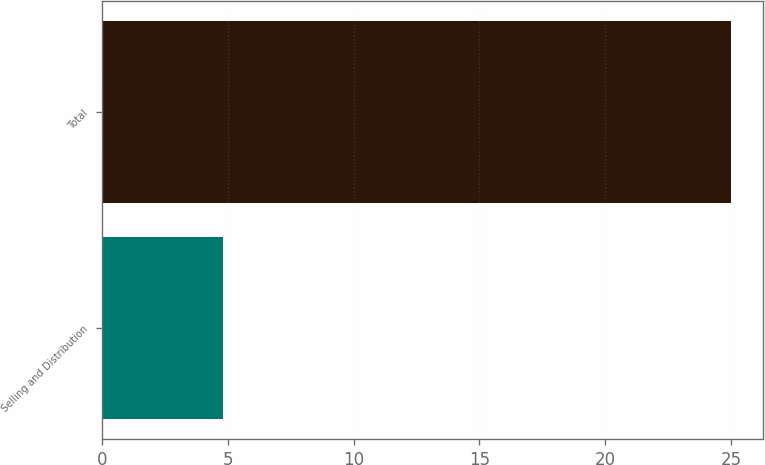Convert chart to OTSL. <chart><loc_0><loc_0><loc_500><loc_500><bar_chart><fcel>Selling and Distribution<fcel>Total<nl><fcel>4.8<fcel>25<nl></chart> 